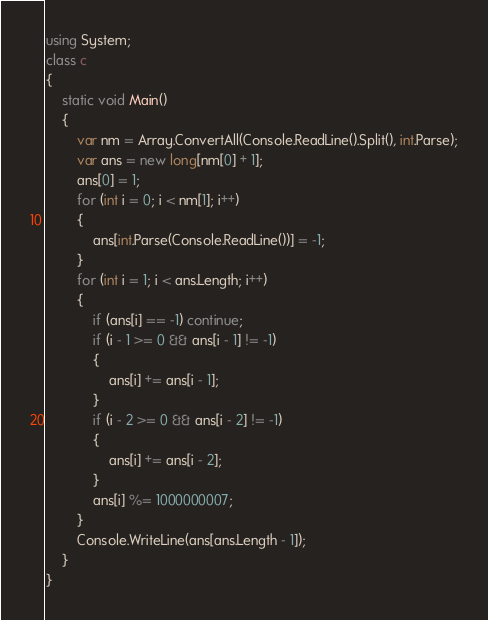Convert code to text. <code><loc_0><loc_0><loc_500><loc_500><_C#_>using System;
class c
{
    static void Main()
    {
        var nm = Array.ConvertAll(Console.ReadLine().Split(), int.Parse);
        var ans = new long[nm[0] + 1];
        ans[0] = 1;
        for (int i = 0; i < nm[1]; i++)
        {
            ans[int.Parse(Console.ReadLine())] = -1;
        }
        for (int i = 1; i < ans.Length; i++)
        {
            if (ans[i] == -1) continue;
            if (i - 1 >= 0 && ans[i - 1] != -1)
            {
                ans[i] += ans[i - 1];
            }
            if (i - 2 >= 0 && ans[i - 2] != -1)
            {
                ans[i] += ans[i - 2];
            }
            ans[i] %= 1000000007;
        }
        Console.WriteLine(ans[ans.Length - 1]);
    }
}</code> 